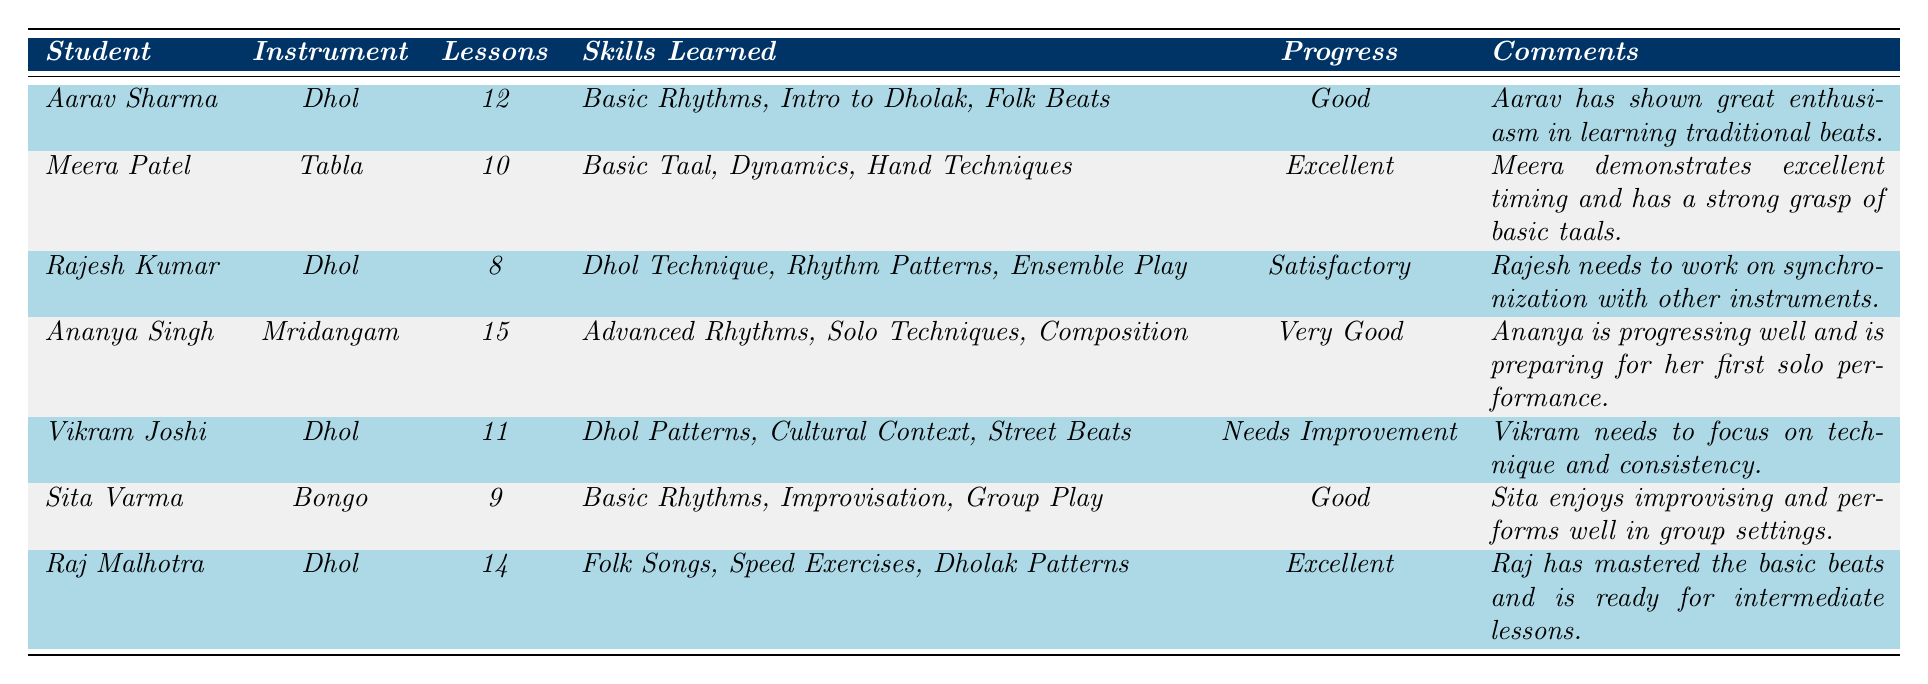What instrument does Aarav Sharma play? Aarav Sharma is listed under the "Instrument" column, and the entry shows that he plays the Dhol.
Answer: Dhol How many lessons did Raj Malhotra attend? Raj Malhotra's entry in the table indicates that he attended a total of 14 lessons.
Answer: 14 What skills did Vikram Joshi learn? Vikram Joshi's skills are listed under the "Skills Learned" column, and they include "Dhol Patterns," "Cultural Context of Dhol," and "Street Beats."
Answer: Dhol Patterns, Cultural Context of Dhol, Street Beats Who has the highest progress rating among Dhol players? The Dhol players include Aarav Sharma, Rajesh Kumar, Vikram Joshi, and Raj Malhotra. Among them, Raj Malhotra has the highest rating, which is "Excellent."
Answer: Raj Malhotra How many total lessons were attended by all students playing Dhol? The total lessons attended by Dhol players (Aarav Sharma: 12, Rajesh Kumar: 8, Vikram Joshi: 11, Raj Malhotra: 14) is calculated as 12 + 8 + 11 + 14 = 45.
Answer: 45 Which student has shown the most improvement according to the comments? By evaluating the comments, Raj Malhotra is noted to have mastered the basic beats and is ready for intermediate lessons, indicating significant progress.
Answer: Raj Malhotra Is Meera Patel's progress rating better than Aarav Sharma's? Meera Patel has an "Excellent" progress rating while Aarav Sharma has a "Good" rating, indicating that Meera Patel's rating is indeed better.
Answer: Yes What is the average number of lessons attended by all students? Summing the lessons attended (12 + 10 + 8 + 15 + 11 + 9 + 14 = 89) gives a total of 89 lessons. Dividing by the 7 students yields an average of 89 / 7 = 12.71 (approximately).
Answer: 12.71 Which student is preparing for their first solo performance? Ananya Singh is noted in the comments to be preparing for her first solo performance.
Answer: Ananya Singh Does Sita Varma play a traditional Indian instrument? Sita Varma plays the Bongo, which is not classified as a traditional Indian instrument like Dhol or Tabla. Therefore, the answer is no.
Answer: No 